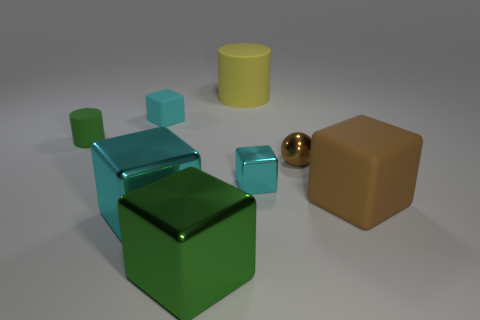Do the cyan shiny cube that is right of the yellow object and the small cyan matte block have the same size?
Provide a short and direct response. Yes. What size is the object that is to the right of the cyan rubber cube and behind the brown metal object?
Keep it short and to the point. Large. What number of other objects are there of the same shape as the large yellow thing?
Keep it short and to the point. 1. What number of other things are made of the same material as the large green thing?
Your answer should be very brief. 3. There is a brown thing that is the same shape as the large cyan thing; what is its size?
Give a very brief answer. Large. Do the tiny ball and the large cylinder have the same color?
Your answer should be compact. No. There is a large thing that is in front of the small metal ball and behind the big cyan thing; what is its color?
Offer a terse response. Brown. How many things are either tiny objects left of the large yellow thing or big brown blocks?
Offer a very short reply. 3. What color is the other rubber thing that is the same shape as the large brown rubber thing?
Ensure brevity in your answer.  Cyan. There is a big brown thing; is its shape the same as the cyan shiny object right of the yellow object?
Your answer should be very brief. Yes. 